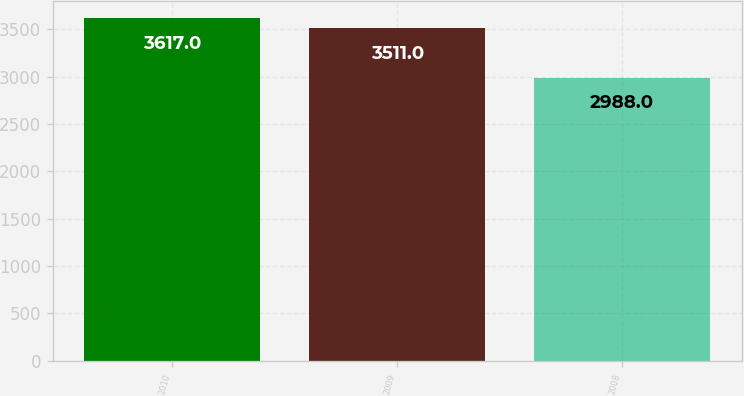Convert chart to OTSL. <chart><loc_0><loc_0><loc_500><loc_500><bar_chart><fcel>2010<fcel>2009<fcel>2008<nl><fcel>3617<fcel>3511<fcel>2988<nl></chart> 